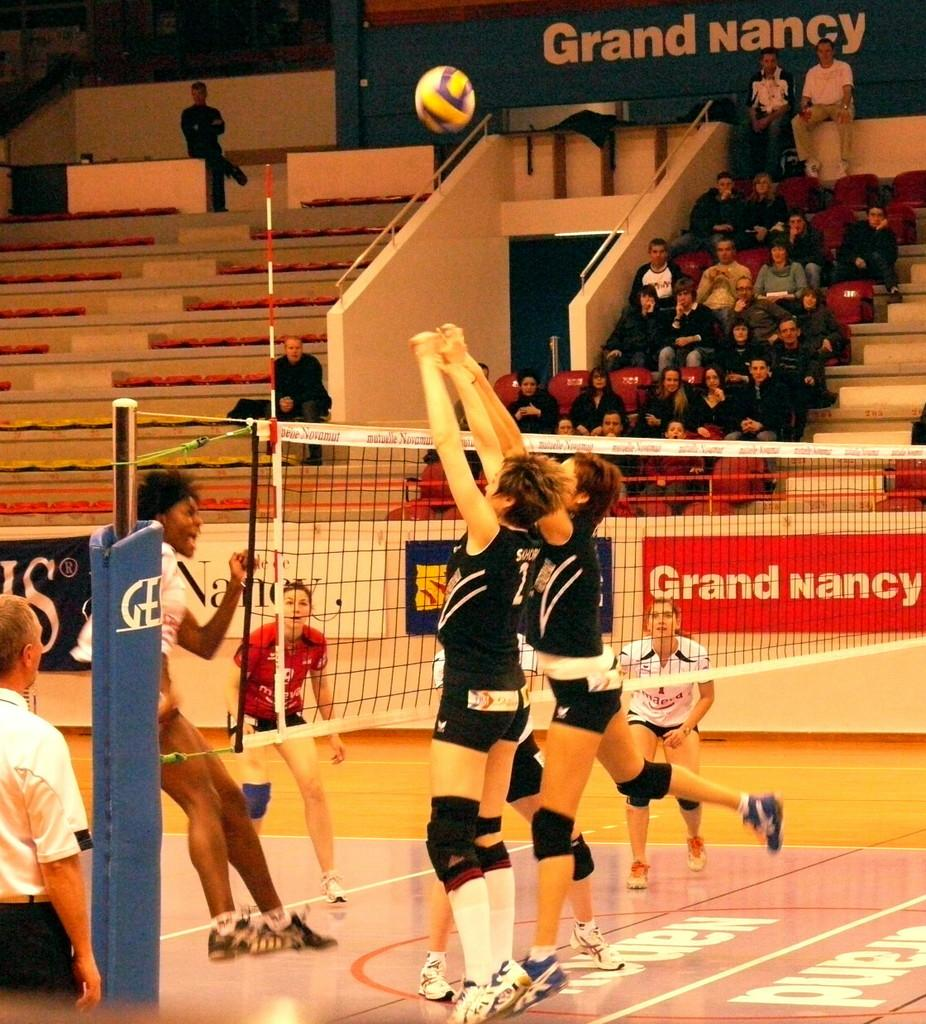<image>
Offer a succinct explanation of the picture presented. Volleyball players are in action, with a banner for Grand Nancy on the side of the court. 